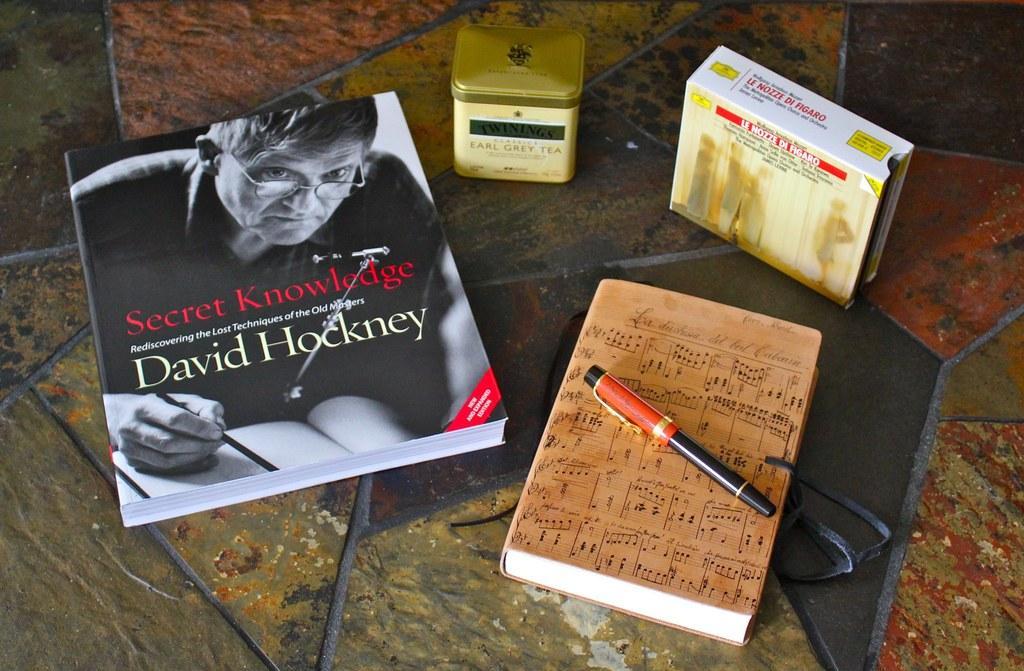How would you summarize this image in a sentence or two? In this image, we can see books, container and box on the floor. Here there is a pen on the book. Here we can see a person on the book. 